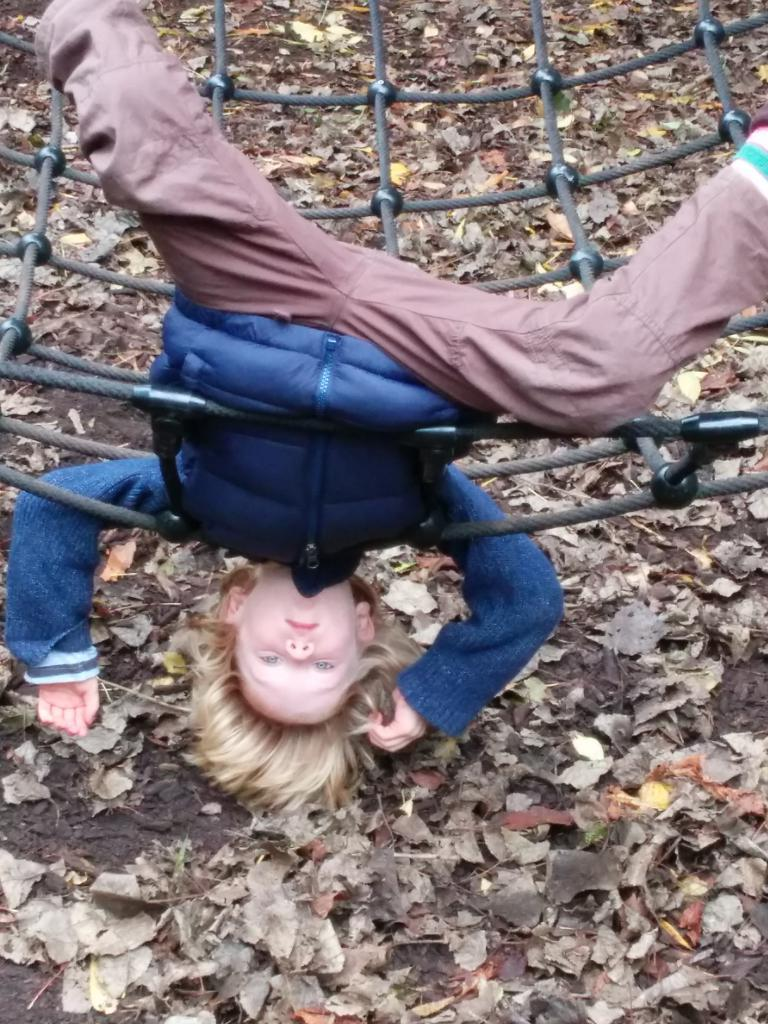What is the main subject of the image? The main subject of the image is a kid. How is the kid positioned in the image? The kid is upside down in a net. What can be seen on the ground in the image? There are dry leaves on the surface in the image. Where is the faucet located in the image? There is no faucet present in the image. What type of haircut does the kid have in the image? The image does not show the kid's haircut, as the focus is on their position in the net. 